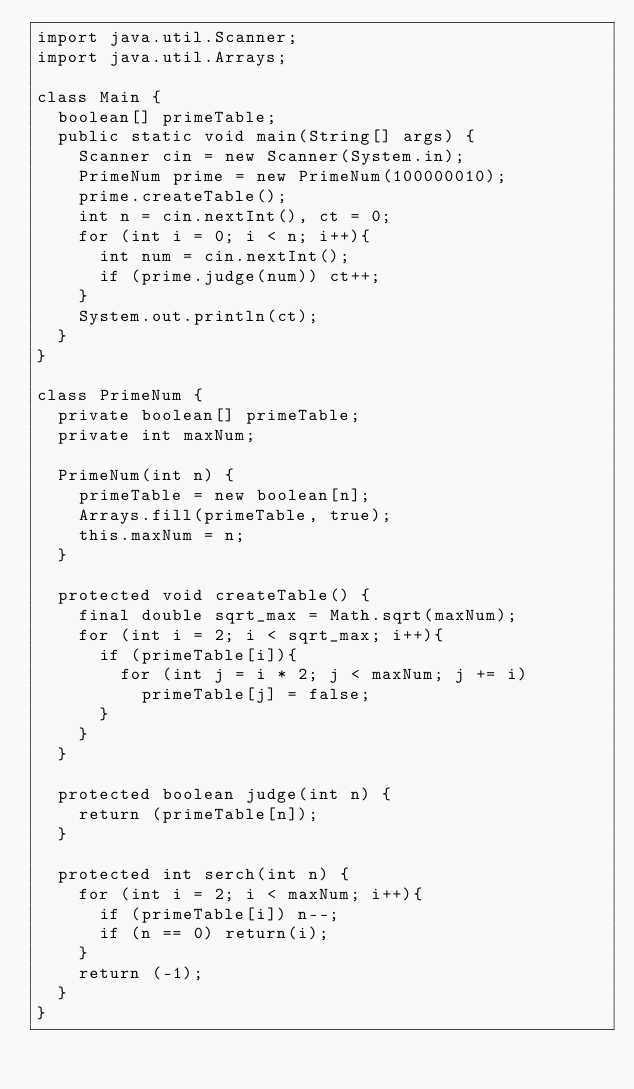Convert code to text. <code><loc_0><loc_0><loc_500><loc_500><_Java_>import java.util.Scanner;
import java.util.Arrays;

class Main {
  boolean[] primeTable;
  public static void main(String[] args) {
    Scanner cin = new Scanner(System.in);
    PrimeNum prime = new PrimeNum(100000010);
    prime.createTable();
    int n = cin.nextInt(), ct = 0;
    for (int i = 0; i < n; i++){
      int num = cin.nextInt();
      if (prime.judge(num)) ct++;
    }
    System.out.println(ct);
  }
}

class PrimeNum {
  private boolean[] primeTable;
  private int maxNum;
  
  PrimeNum(int n) {
    primeTable = new boolean[n];
    Arrays.fill(primeTable, true);
    this.maxNum = n;
  }

  protected void createTable() {
    final double sqrt_max = Math.sqrt(maxNum);
    for (int i = 2; i < sqrt_max; i++){
      if (primeTable[i]){
        for (int j = i * 2; j < maxNum; j += i)
          primeTable[j] = false;
      }
    }
  }

  protected boolean judge(int n) {
    return (primeTable[n]);
  }

  protected int serch(int n) {
    for (int i = 2; i < maxNum; i++){
      if (primeTable[i]) n--;
      if (n == 0) return(i);
    }
    return (-1);
  }
}</code> 